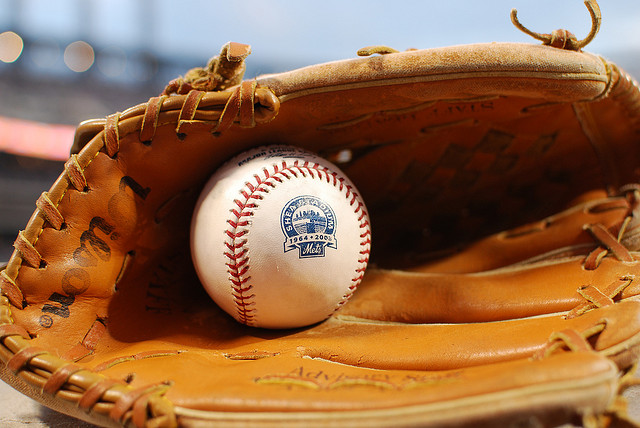Identify the text contained in this image. Wilson 2000 SHEA 